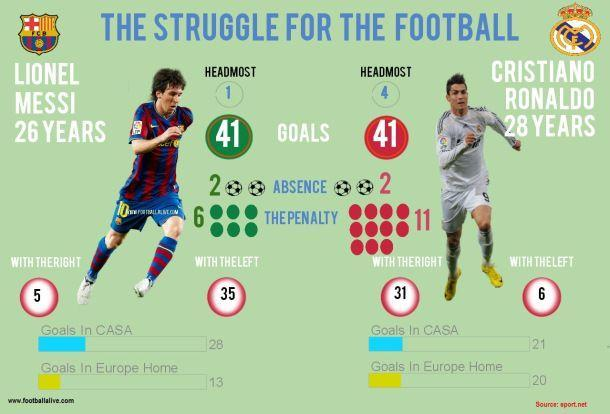Who scored 4 goals with his head?
Answer the question with a short phrase. Ronaldo How many goals did Ronaldo score with left foot? 6 Who scored 35 goals with the left foot? Messi Who scored 31 goals with his right foot? Ronaldo Who scored 21 goals in CASA? Ronaldo Who scored 13 goals in Europe Home? Messi How many goals did Messi score with right foot? 5 How many goals were scored by Messi in CASA? 28 How many goals did Messi score with his head? 1 How many goals were scored by Ronaldo in Europe Home? 20 